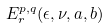<formula> <loc_0><loc_0><loc_500><loc_500>E _ { r } ^ { p , q } ( \epsilon , \nu , a , b )</formula> 